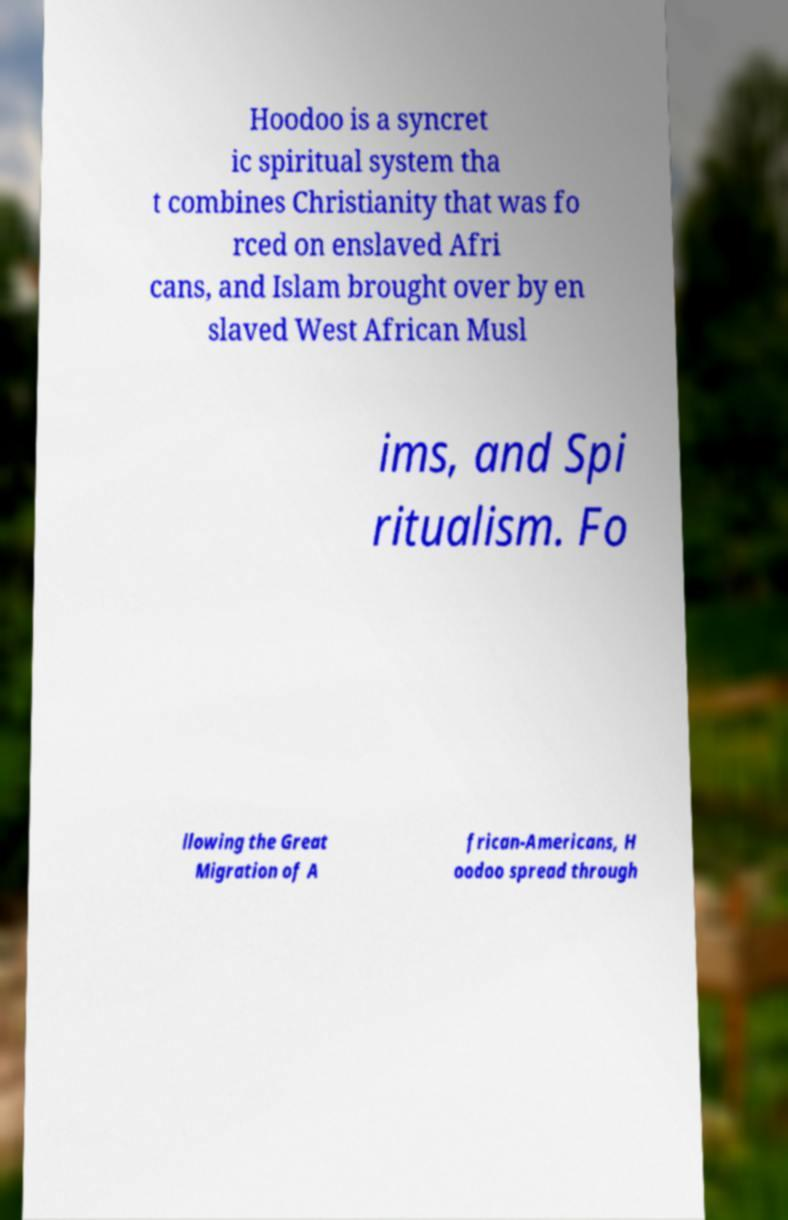Please identify and transcribe the text found in this image. Hoodoo is a syncret ic spiritual system tha t combines Christianity that was fo rced on enslaved Afri cans, and Islam brought over by en slaved West African Musl ims, and Spi ritualism. Fo llowing the Great Migration of A frican-Americans, H oodoo spread through 